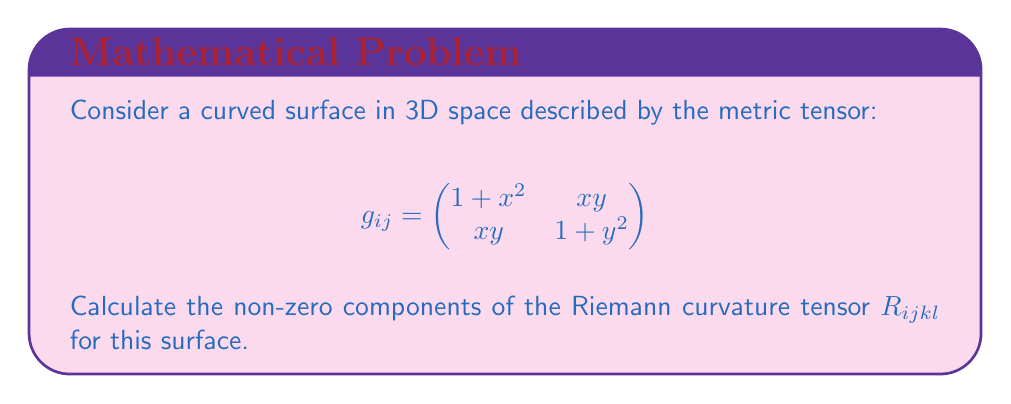Solve this math problem. To calculate the Riemann curvature tensor, we'll follow these steps:

1) First, we need to calculate the Christoffel symbols $\Gamma^i_{jk}$:

   $$\Gamma^i_{jk} = \frac{1}{2}g^{im}(\partial_j g_{km} + \partial_k g_{jm} - \partial_m g_{jk})$$

   where $g^{im}$ is the inverse metric tensor.

2) The inverse metric tensor is:

   $$g^{ij} = \frac{1}{(1+x^2)(1+y^2)-x^2y^2} \begin{pmatrix}
   1+y^2 & -xy \\
   -xy & 1+x^2
   \end{pmatrix}$$

3) Calculating the non-zero Christoffel symbols:

   $$\Gamma^1_{11} = \frac{x}{1+x^2}, \quad \Gamma^1_{12} = \Gamma^1_{21} = \frac{y}{2(1+x^2)}$$
   $$\Gamma^2_{12} = \Gamma^2_{21} = \frac{x}{2(1+y^2)}, \quad \Gamma^2_{22} = \frac{y}{1+y^2}$$

4) The Riemann curvature tensor is given by:

   $$R^i_{jkl} = \partial_k \Gamma^i_{jl} - \partial_l \Gamma^i_{jk} + \Gamma^m_{jl}\Gamma^i_{mk} - \Gamma^m_{jk}\Gamma^i_{ml}$$

5) Calculating the non-zero components:

   $$R^1_{212} = \partial_1 \Gamma^1_{22} - \partial_2 \Gamma^1_{21} + \Gamma^1_{22}\Gamma^1_{11} + \Gamma^2_{22}\Gamma^1_{21} - \Gamma^1_{21}\Gamma^1_{12} - \Gamma^2_{21}\Gamma^1_{22}$$
   
   $$R^2_{121} = \partial_2 \Gamma^2_{11} - \partial_1 \Gamma^2_{21} + \Gamma^1_{11}\Gamma^2_{21} + \Gamma^2_{11}\Gamma^2_{22} - \Gamma^1_{21}\Gamma^2_{11} - \Gamma^2_{21}\Gamma^2_{12}$$

6) After simplification:

   $$R^1_{212} = -R^2_{121} = \frac{1}{(1+x^2)(1+y^2)}$$

7) The covariant components are:

   $$R_{1212} = g_{1i}R^i_{212} = \frac{1+x^2}{(1+x^2)(1+y^2)} = \frac{1}{1+y^2}$$

   $$R_{2121} = g_{2i}R^i_{121} = \frac{1+y^2}{(1+x^2)(1+y^2)} = \frac{1}{1+x^2}$$
Answer: $R_{1212} = \frac{1}{1+y^2}$, $R_{2121} = \frac{1}{1+x^2}$ 